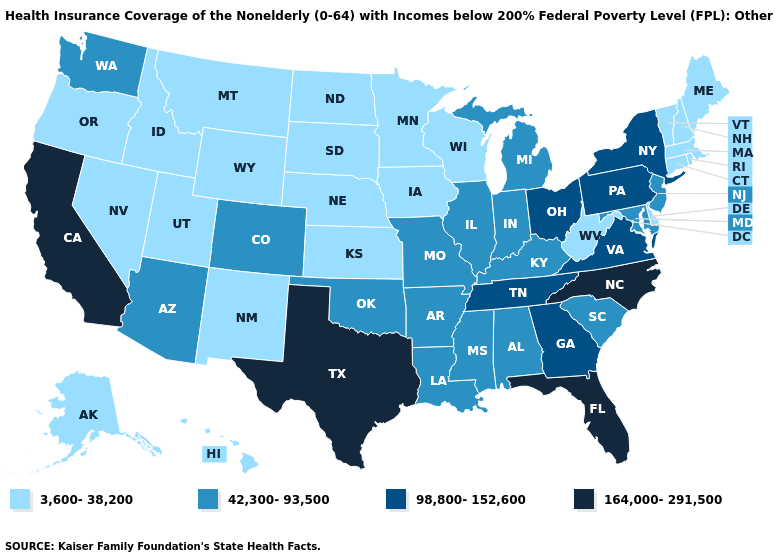What is the lowest value in the West?
Give a very brief answer. 3,600-38,200. What is the value of Wisconsin?
Quick response, please. 3,600-38,200. What is the lowest value in the USA?
Write a very short answer. 3,600-38,200. Does Wisconsin have a lower value than North Dakota?
Be succinct. No. Does Indiana have the highest value in the MidWest?
Quick response, please. No. What is the value of Washington?
Short answer required. 42,300-93,500. What is the lowest value in states that border New Jersey?
Short answer required. 3,600-38,200. Name the states that have a value in the range 42,300-93,500?
Answer briefly. Alabama, Arizona, Arkansas, Colorado, Illinois, Indiana, Kentucky, Louisiana, Maryland, Michigan, Mississippi, Missouri, New Jersey, Oklahoma, South Carolina, Washington. What is the lowest value in the USA?
Answer briefly. 3,600-38,200. Name the states that have a value in the range 3,600-38,200?
Concise answer only. Alaska, Connecticut, Delaware, Hawaii, Idaho, Iowa, Kansas, Maine, Massachusetts, Minnesota, Montana, Nebraska, Nevada, New Hampshire, New Mexico, North Dakota, Oregon, Rhode Island, South Dakota, Utah, Vermont, West Virginia, Wisconsin, Wyoming. Does the first symbol in the legend represent the smallest category?
Answer briefly. Yes. What is the value of Alabama?
Answer briefly. 42,300-93,500. What is the highest value in the South ?
Give a very brief answer. 164,000-291,500. Does Florida have the highest value in the USA?
Quick response, please. Yes. Does South Carolina have a lower value than Florida?
Give a very brief answer. Yes. 